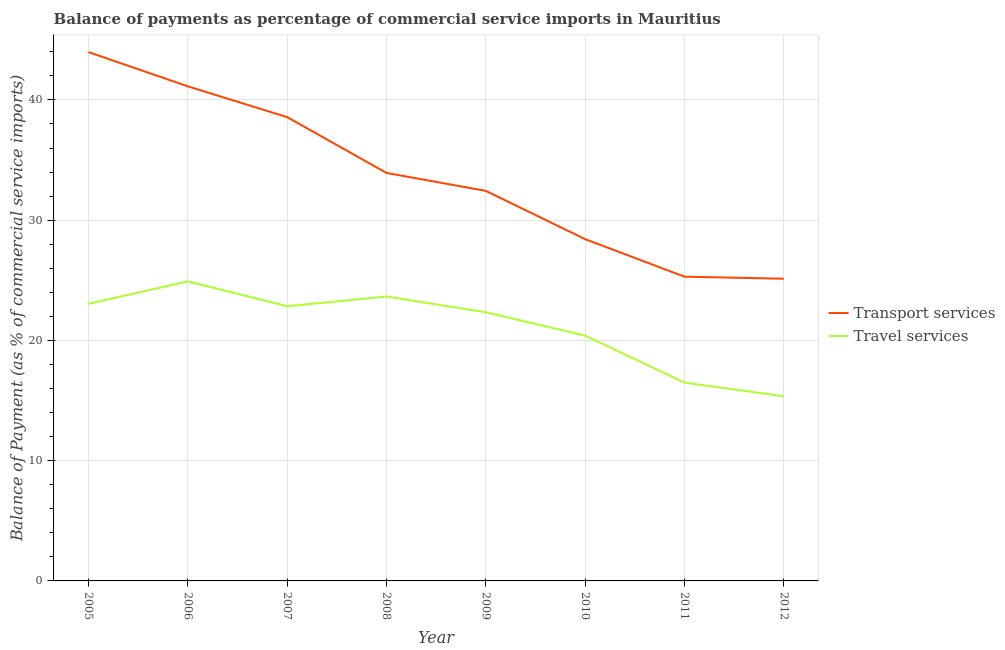Is the number of lines equal to the number of legend labels?
Offer a very short reply. Yes. What is the balance of payments of transport services in 2009?
Keep it short and to the point. 32.44. Across all years, what is the maximum balance of payments of travel services?
Offer a terse response. 24.91. Across all years, what is the minimum balance of payments of travel services?
Provide a succinct answer. 15.35. What is the total balance of payments of travel services in the graph?
Your response must be concise. 169.04. What is the difference between the balance of payments of travel services in 2006 and that in 2010?
Give a very brief answer. 4.51. What is the difference between the balance of payments of travel services in 2005 and the balance of payments of transport services in 2009?
Provide a short and direct response. -9.39. What is the average balance of payments of travel services per year?
Ensure brevity in your answer.  21.13. In the year 2012, what is the difference between the balance of payments of travel services and balance of payments of transport services?
Offer a very short reply. -9.78. In how many years, is the balance of payments of transport services greater than 14 %?
Ensure brevity in your answer.  8. What is the ratio of the balance of payments of travel services in 2008 to that in 2010?
Make the answer very short. 1.16. What is the difference between the highest and the second highest balance of payments of transport services?
Give a very brief answer. 2.85. What is the difference between the highest and the lowest balance of payments of transport services?
Ensure brevity in your answer.  18.85. Does the balance of payments of transport services monotonically increase over the years?
Offer a terse response. No. How many years are there in the graph?
Offer a very short reply. 8. Does the graph contain any zero values?
Provide a short and direct response. No. Does the graph contain grids?
Give a very brief answer. Yes. How many legend labels are there?
Make the answer very short. 2. How are the legend labels stacked?
Keep it short and to the point. Vertical. What is the title of the graph?
Offer a terse response. Balance of payments as percentage of commercial service imports in Mauritius. What is the label or title of the Y-axis?
Keep it short and to the point. Balance of Payment (as % of commercial service imports). What is the Balance of Payment (as % of commercial service imports) in Transport services in 2005?
Give a very brief answer. 43.98. What is the Balance of Payment (as % of commercial service imports) of Travel services in 2005?
Ensure brevity in your answer.  23.05. What is the Balance of Payment (as % of commercial service imports) in Transport services in 2006?
Ensure brevity in your answer.  41.13. What is the Balance of Payment (as % of commercial service imports) in Travel services in 2006?
Your response must be concise. 24.91. What is the Balance of Payment (as % of commercial service imports) in Transport services in 2007?
Your answer should be compact. 38.57. What is the Balance of Payment (as % of commercial service imports) of Travel services in 2007?
Your response must be concise. 22.84. What is the Balance of Payment (as % of commercial service imports) in Transport services in 2008?
Offer a very short reply. 33.93. What is the Balance of Payment (as % of commercial service imports) of Travel services in 2008?
Your answer should be very brief. 23.65. What is the Balance of Payment (as % of commercial service imports) of Transport services in 2009?
Your answer should be compact. 32.44. What is the Balance of Payment (as % of commercial service imports) of Travel services in 2009?
Give a very brief answer. 22.34. What is the Balance of Payment (as % of commercial service imports) in Transport services in 2010?
Keep it short and to the point. 28.42. What is the Balance of Payment (as % of commercial service imports) in Travel services in 2010?
Offer a very short reply. 20.4. What is the Balance of Payment (as % of commercial service imports) of Transport services in 2011?
Provide a short and direct response. 25.3. What is the Balance of Payment (as % of commercial service imports) in Travel services in 2011?
Your answer should be very brief. 16.49. What is the Balance of Payment (as % of commercial service imports) in Transport services in 2012?
Provide a succinct answer. 25.13. What is the Balance of Payment (as % of commercial service imports) of Travel services in 2012?
Your answer should be compact. 15.35. Across all years, what is the maximum Balance of Payment (as % of commercial service imports) in Transport services?
Your answer should be compact. 43.98. Across all years, what is the maximum Balance of Payment (as % of commercial service imports) of Travel services?
Provide a succinct answer. 24.91. Across all years, what is the minimum Balance of Payment (as % of commercial service imports) in Transport services?
Keep it short and to the point. 25.13. Across all years, what is the minimum Balance of Payment (as % of commercial service imports) in Travel services?
Make the answer very short. 15.35. What is the total Balance of Payment (as % of commercial service imports) of Transport services in the graph?
Give a very brief answer. 268.9. What is the total Balance of Payment (as % of commercial service imports) in Travel services in the graph?
Give a very brief answer. 169.04. What is the difference between the Balance of Payment (as % of commercial service imports) of Transport services in 2005 and that in 2006?
Keep it short and to the point. 2.85. What is the difference between the Balance of Payment (as % of commercial service imports) in Travel services in 2005 and that in 2006?
Make the answer very short. -1.86. What is the difference between the Balance of Payment (as % of commercial service imports) of Transport services in 2005 and that in 2007?
Give a very brief answer. 5.41. What is the difference between the Balance of Payment (as % of commercial service imports) in Travel services in 2005 and that in 2007?
Provide a short and direct response. 0.2. What is the difference between the Balance of Payment (as % of commercial service imports) of Transport services in 2005 and that in 2008?
Make the answer very short. 10.05. What is the difference between the Balance of Payment (as % of commercial service imports) in Travel services in 2005 and that in 2008?
Offer a terse response. -0.61. What is the difference between the Balance of Payment (as % of commercial service imports) in Transport services in 2005 and that in 2009?
Ensure brevity in your answer.  11.54. What is the difference between the Balance of Payment (as % of commercial service imports) of Travel services in 2005 and that in 2009?
Keep it short and to the point. 0.7. What is the difference between the Balance of Payment (as % of commercial service imports) in Transport services in 2005 and that in 2010?
Provide a short and direct response. 15.56. What is the difference between the Balance of Payment (as % of commercial service imports) in Travel services in 2005 and that in 2010?
Provide a succinct answer. 2.64. What is the difference between the Balance of Payment (as % of commercial service imports) in Transport services in 2005 and that in 2011?
Ensure brevity in your answer.  18.68. What is the difference between the Balance of Payment (as % of commercial service imports) in Travel services in 2005 and that in 2011?
Ensure brevity in your answer.  6.55. What is the difference between the Balance of Payment (as % of commercial service imports) of Transport services in 2005 and that in 2012?
Keep it short and to the point. 18.85. What is the difference between the Balance of Payment (as % of commercial service imports) of Travel services in 2005 and that in 2012?
Offer a very short reply. 7.69. What is the difference between the Balance of Payment (as % of commercial service imports) of Transport services in 2006 and that in 2007?
Make the answer very short. 2.56. What is the difference between the Balance of Payment (as % of commercial service imports) in Travel services in 2006 and that in 2007?
Offer a terse response. 2.06. What is the difference between the Balance of Payment (as % of commercial service imports) in Transport services in 2006 and that in 2008?
Offer a terse response. 7.2. What is the difference between the Balance of Payment (as % of commercial service imports) in Travel services in 2006 and that in 2008?
Provide a succinct answer. 1.25. What is the difference between the Balance of Payment (as % of commercial service imports) in Transport services in 2006 and that in 2009?
Keep it short and to the point. 8.69. What is the difference between the Balance of Payment (as % of commercial service imports) in Travel services in 2006 and that in 2009?
Your response must be concise. 2.57. What is the difference between the Balance of Payment (as % of commercial service imports) of Transport services in 2006 and that in 2010?
Offer a terse response. 12.71. What is the difference between the Balance of Payment (as % of commercial service imports) of Travel services in 2006 and that in 2010?
Make the answer very short. 4.51. What is the difference between the Balance of Payment (as % of commercial service imports) of Transport services in 2006 and that in 2011?
Offer a terse response. 15.83. What is the difference between the Balance of Payment (as % of commercial service imports) of Travel services in 2006 and that in 2011?
Give a very brief answer. 8.41. What is the difference between the Balance of Payment (as % of commercial service imports) in Transport services in 2006 and that in 2012?
Your answer should be very brief. 16. What is the difference between the Balance of Payment (as % of commercial service imports) of Travel services in 2006 and that in 2012?
Keep it short and to the point. 9.55. What is the difference between the Balance of Payment (as % of commercial service imports) in Transport services in 2007 and that in 2008?
Ensure brevity in your answer.  4.64. What is the difference between the Balance of Payment (as % of commercial service imports) in Travel services in 2007 and that in 2008?
Your answer should be very brief. -0.81. What is the difference between the Balance of Payment (as % of commercial service imports) in Transport services in 2007 and that in 2009?
Provide a succinct answer. 6.14. What is the difference between the Balance of Payment (as % of commercial service imports) of Travel services in 2007 and that in 2009?
Your answer should be compact. 0.5. What is the difference between the Balance of Payment (as % of commercial service imports) of Transport services in 2007 and that in 2010?
Your response must be concise. 10.15. What is the difference between the Balance of Payment (as % of commercial service imports) of Travel services in 2007 and that in 2010?
Your answer should be compact. 2.44. What is the difference between the Balance of Payment (as % of commercial service imports) of Transport services in 2007 and that in 2011?
Your answer should be very brief. 13.27. What is the difference between the Balance of Payment (as % of commercial service imports) of Travel services in 2007 and that in 2011?
Your answer should be compact. 6.35. What is the difference between the Balance of Payment (as % of commercial service imports) in Transport services in 2007 and that in 2012?
Make the answer very short. 13.44. What is the difference between the Balance of Payment (as % of commercial service imports) of Travel services in 2007 and that in 2012?
Offer a very short reply. 7.49. What is the difference between the Balance of Payment (as % of commercial service imports) of Transport services in 2008 and that in 2009?
Offer a very short reply. 1.49. What is the difference between the Balance of Payment (as % of commercial service imports) of Travel services in 2008 and that in 2009?
Give a very brief answer. 1.31. What is the difference between the Balance of Payment (as % of commercial service imports) of Transport services in 2008 and that in 2010?
Offer a very short reply. 5.51. What is the difference between the Balance of Payment (as % of commercial service imports) of Travel services in 2008 and that in 2010?
Your response must be concise. 3.25. What is the difference between the Balance of Payment (as % of commercial service imports) in Transport services in 2008 and that in 2011?
Provide a short and direct response. 8.63. What is the difference between the Balance of Payment (as % of commercial service imports) in Travel services in 2008 and that in 2011?
Provide a succinct answer. 7.16. What is the difference between the Balance of Payment (as % of commercial service imports) of Transport services in 2008 and that in 2012?
Your answer should be compact. 8.8. What is the difference between the Balance of Payment (as % of commercial service imports) of Travel services in 2008 and that in 2012?
Make the answer very short. 8.3. What is the difference between the Balance of Payment (as % of commercial service imports) in Transport services in 2009 and that in 2010?
Provide a succinct answer. 4.01. What is the difference between the Balance of Payment (as % of commercial service imports) in Travel services in 2009 and that in 2010?
Provide a short and direct response. 1.94. What is the difference between the Balance of Payment (as % of commercial service imports) of Transport services in 2009 and that in 2011?
Provide a short and direct response. 7.14. What is the difference between the Balance of Payment (as % of commercial service imports) in Travel services in 2009 and that in 2011?
Your answer should be compact. 5.85. What is the difference between the Balance of Payment (as % of commercial service imports) in Transport services in 2009 and that in 2012?
Keep it short and to the point. 7.3. What is the difference between the Balance of Payment (as % of commercial service imports) in Travel services in 2009 and that in 2012?
Offer a terse response. 6.99. What is the difference between the Balance of Payment (as % of commercial service imports) of Transport services in 2010 and that in 2011?
Give a very brief answer. 3.12. What is the difference between the Balance of Payment (as % of commercial service imports) of Travel services in 2010 and that in 2011?
Make the answer very short. 3.91. What is the difference between the Balance of Payment (as % of commercial service imports) of Transport services in 2010 and that in 2012?
Give a very brief answer. 3.29. What is the difference between the Balance of Payment (as % of commercial service imports) in Travel services in 2010 and that in 2012?
Your response must be concise. 5.05. What is the difference between the Balance of Payment (as % of commercial service imports) in Transport services in 2011 and that in 2012?
Keep it short and to the point. 0.17. What is the difference between the Balance of Payment (as % of commercial service imports) in Travel services in 2011 and that in 2012?
Provide a short and direct response. 1.14. What is the difference between the Balance of Payment (as % of commercial service imports) in Transport services in 2005 and the Balance of Payment (as % of commercial service imports) in Travel services in 2006?
Provide a succinct answer. 19.07. What is the difference between the Balance of Payment (as % of commercial service imports) of Transport services in 2005 and the Balance of Payment (as % of commercial service imports) of Travel services in 2007?
Make the answer very short. 21.14. What is the difference between the Balance of Payment (as % of commercial service imports) of Transport services in 2005 and the Balance of Payment (as % of commercial service imports) of Travel services in 2008?
Provide a short and direct response. 20.33. What is the difference between the Balance of Payment (as % of commercial service imports) in Transport services in 2005 and the Balance of Payment (as % of commercial service imports) in Travel services in 2009?
Provide a succinct answer. 21.64. What is the difference between the Balance of Payment (as % of commercial service imports) of Transport services in 2005 and the Balance of Payment (as % of commercial service imports) of Travel services in 2010?
Ensure brevity in your answer.  23.58. What is the difference between the Balance of Payment (as % of commercial service imports) in Transport services in 2005 and the Balance of Payment (as % of commercial service imports) in Travel services in 2011?
Provide a succinct answer. 27.48. What is the difference between the Balance of Payment (as % of commercial service imports) of Transport services in 2005 and the Balance of Payment (as % of commercial service imports) of Travel services in 2012?
Make the answer very short. 28.62. What is the difference between the Balance of Payment (as % of commercial service imports) of Transport services in 2006 and the Balance of Payment (as % of commercial service imports) of Travel services in 2007?
Provide a succinct answer. 18.29. What is the difference between the Balance of Payment (as % of commercial service imports) of Transport services in 2006 and the Balance of Payment (as % of commercial service imports) of Travel services in 2008?
Provide a short and direct response. 17.48. What is the difference between the Balance of Payment (as % of commercial service imports) in Transport services in 2006 and the Balance of Payment (as % of commercial service imports) in Travel services in 2009?
Keep it short and to the point. 18.79. What is the difference between the Balance of Payment (as % of commercial service imports) in Transport services in 2006 and the Balance of Payment (as % of commercial service imports) in Travel services in 2010?
Provide a succinct answer. 20.73. What is the difference between the Balance of Payment (as % of commercial service imports) of Transport services in 2006 and the Balance of Payment (as % of commercial service imports) of Travel services in 2011?
Your answer should be compact. 24.64. What is the difference between the Balance of Payment (as % of commercial service imports) of Transport services in 2006 and the Balance of Payment (as % of commercial service imports) of Travel services in 2012?
Keep it short and to the point. 25.78. What is the difference between the Balance of Payment (as % of commercial service imports) of Transport services in 2007 and the Balance of Payment (as % of commercial service imports) of Travel services in 2008?
Provide a succinct answer. 14.92. What is the difference between the Balance of Payment (as % of commercial service imports) in Transport services in 2007 and the Balance of Payment (as % of commercial service imports) in Travel services in 2009?
Provide a short and direct response. 16.23. What is the difference between the Balance of Payment (as % of commercial service imports) in Transport services in 2007 and the Balance of Payment (as % of commercial service imports) in Travel services in 2010?
Your answer should be very brief. 18.17. What is the difference between the Balance of Payment (as % of commercial service imports) of Transport services in 2007 and the Balance of Payment (as % of commercial service imports) of Travel services in 2011?
Provide a short and direct response. 22.08. What is the difference between the Balance of Payment (as % of commercial service imports) of Transport services in 2007 and the Balance of Payment (as % of commercial service imports) of Travel services in 2012?
Offer a very short reply. 23.22. What is the difference between the Balance of Payment (as % of commercial service imports) in Transport services in 2008 and the Balance of Payment (as % of commercial service imports) in Travel services in 2009?
Make the answer very short. 11.59. What is the difference between the Balance of Payment (as % of commercial service imports) of Transport services in 2008 and the Balance of Payment (as % of commercial service imports) of Travel services in 2010?
Provide a short and direct response. 13.53. What is the difference between the Balance of Payment (as % of commercial service imports) in Transport services in 2008 and the Balance of Payment (as % of commercial service imports) in Travel services in 2011?
Provide a succinct answer. 17.43. What is the difference between the Balance of Payment (as % of commercial service imports) of Transport services in 2008 and the Balance of Payment (as % of commercial service imports) of Travel services in 2012?
Provide a succinct answer. 18.57. What is the difference between the Balance of Payment (as % of commercial service imports) of Transport services in 2009 and the Balance of Payment (as % of commercial service imports) of Travel services in 2010?
Provide a succinct answer. 12.04. What is the difference between the Balance of Payment (as % of commercial service imports) of Transport services in 2009 and the Balance of Payment (as % of commercial service imports) of Travel services in 2011?
Provide a short and direct response. 15.94. What is the difference between the Balance of Payment (as % of commercial service imports) in Transport services in 2009 and the Balance of Payment (as % of commercial service imports) in Travel services in 2012?
Ensure brevity in your answer.  17.08. What is the difference between the Balance of Payment (as % of commercial service imports) in Transport services in 2010 and the Balance of Payment (as % of commercial service imports) in Travel services in 2011?
Provide a short and direct response. 11.93. What is the difference between the Balance of Payment (as % of commercial service imports) of Transport services in 2010 and the Balance of Payment (as % of commercial service imports) of Travel services in 2012?
Offer a terse response. 13.07. What is the difference between the Balance of Payment (as % of commercial service imports) in Transport services in 2011 and the Balance of Payment (as % of commercial service imports) in Travel services in 2012?
Ensure brevity in your answer.  9.95. What is the average Balance of Payment (as % of commercial service imports) of Transport services per year?
Keep it short and to the point. 33.61. What is the average Balance of Payment (as % of commercial service imports) of Travel services per year?
Offer a terse response. 21.13. In the year 2005, what is the difference between the Balance of Payment (as % of commercial service imports) of Transport services and Balance of Payment (as % of commercial service imports) of Travel services?
Provide a succinct answer. 20.93. In the year 2006, what is the difference between the Balance of Payment (as % of commercial service imports) in Transport services and Balance of Payment (as % of commercial service imports) in Travel services?
Provide a short and direct response. 16.22. In the year 2007, what is the difference between the Balance of Payment (as % of commercial service imports) in Transport services and Balance of Payment (as % of commercial service imports) in Travel services?
Offer a very short reply. 15.73. In the year 2008, what is the difference between the Balance of Payment (as % of commercial service imports) in Transport services and Balance of Payment (as % of commercial service imports) in Travel services?
Make the answer very short. 10.28. In the year 2009, what is the difference between the Balance of Payment (as % of commercial service imports) in Transport services and Balance of Payment (as % of commercial service imports) in Travel services?
Keep it short and to the point. 10.09. In the year 2010, what is the difference between the Balance of Payment (as % of commercial service imports) of Transport services and Balance of Payment (as % of commercial service imports) of Travel services?
Give a very brief answer. 8.02. In the year 2011, what is the difference between the Balance of Payment (as % of commercial service imports) in Transport services and Balance of Payment (as % of commercial service imports) in Travel services?
Offer a very short reply. 8.81. In the year 2012, what is the difference between the Balance of Payment (as % of commercial service imports) in Transport services and Balance of Payment (as % of commercial service imports) in Travel services?
Ensure brevity in your answer.  9.78. What is the ratio of the Balance of Payment (as % of commercial service imports) in Transport services in 2005 to that in 2006?
Your answer should be compact. 1.07. What is the ratio of the Balance of Payment (as % of commercial service imports) of Travel services in 2005 to that in 2006?
Your answer should be very brief. 0.93. What is the ratio of the Balance of Payment (as % of commercial service imports) in Transport services in 2005 to that in 2007?
Your response must be concise. 1.14. What is the ratio of the Balance of Payment (as % of commercial service imports) in Travel services in 2005 to that in 2007?
Provide a succinct answer. 1.01. What is the ratio of the Balance of Payment (as % of commercial service imports) of Transport services in 2005 to that in 2008?
Your answer should be compact. 1.3. What is the ratio of the Balance of Payment (as % of commercial service imports) in Travel services in 2005 to that in 2008?
Ensure brevity in your answer.  0.97. What is the ratio of the Balance of Payment (as % of commercial service imports) in Transport services in 2005 to that in 2009?
Offer a terse response. 1.36. What is the ratio of the Balance of Payment (as % of commercial service imports) of Travel services in 2005 to that in 2009?
Make the answer very short. 1.03. What is the ratio of the Balance of Payment (as % of commercial service imports) in Transport services in 2005 to that in 2010?
Offer a very short reply. 1.55. What is the ratio of the Balance of Payment (as % of commercial service imports) in Travel services in 2005 to that in 2010?
Give a very brief answer. 1.13. What is the ratio of the Balance of Payment (as % of commercial service imports) of Transport services in 2005 to that in 2011?
Your answer should be very brief. 1.74. What is the ratio of the Balance of Payment (as % of commercial service imports) of Travel services in 2005 to that in 2011?
Provide a short and direct response. 1.4. What is the ratio of the Balance of Payment (as % of commercial service imports) of Transport services in 2005 to that in 2012?
Offer a terse response. 1.75. What is the ratio of the Balance of Payment (as % of commercial service imports) in Travel services in 2005 to that in 2012?
Offer a very short reply. 1.5. What is the ratio of the Balance of Payment (as % of commercial service imports) in Transport services in 2006 to that in 2007?
Provide a short and direct response. 1.07. What is the ratio of the Balance of Payment (as % of commercial service imports) in Travel services in 2006 to that in 2007?
Your answer should be very brief. 1.09. What is the ratio of the Balance of Payment (as % of commercial service imports) in Transport services in 2006 to that in 2008?
Provide a succinct answer. 1.21. What is the ratio of the Balance of Payment (as % of commercial service imports) of Travel services in 2006 to that in 2008?
Give a very brief answer. 1.05. What is the ratio of the Balance of Payment (as % of commercial service imports) of Transport services in 2006 to that in 2009?
Keep it short and to the point. 1.27. What is the ratio of the Balance of Payment (as % of commercial service imports) of Travel services in 2006 to that in 2009?
Provide a short and direct response. 1.11. What is the ratio of the Balance of Payment (as % of commercial service imports) of Transport services in 2006 to that in 2010?
Ensure brevity in your answer.  1.45. What is the ratio of the Balance of Payment (as % of commercial service imports) of Travel services in 2006 to that in 2010?
Your answer should be very brief. 1.22. What is the ratio of the Balance of Payment (as % of commercial service imports) of Transport services in 2006 to that in 2011?
Provide a succinct answer. 1.63. What is the ratio of the Balance of Payment (as % of commercial service imports) in Travel services in 2006 to that in 2011?
Provide a succinct answer. 1.51. What is the ratio of the Balance of Payment (as % of commercial service imports) in Transport services in 2006 to that in 2012?
Make the answer very short. 1.64. What is the ratio of the Balance of Payment (as % of commercial service imports) in Travel services in 2006 to that in 2012?
Your answer should be compact. 1.62. What is the ratio of the Balance of Payment (as % of commercial service imports) in Transport services in 2007 to that in 2008?
Your response must be concise. 1.14. What is the ratio of the Balance of Payment (as % of commercial service imports) of Travel services in 2007 to that in 2008?
Ensure brevity in your answer.  0.97. What is the ratio of the Balance of Payment (as % of commercial service imports) in Transport services in 2007 to that in 2009?
Your answer should be compact. 1.19. What is the ratio of the Balance of Payment (as % of commercial service imports) of Travel services in 2007 to that in 2009?
Your response must be concise. 1.02. What is the ratio of the Balance of Payment (as % of commercial service imports) in Transport services in 2007 to that in 2010?
Give a very brief answer. 1.36. What is the ratio of the Balance of Payment (as % of commercial service imports) in Travel services in 2007 to that in 2010?
Keep it short and to the point. 1.12. What is the ratio of the Balance of Payment (as % of commercial service imports) of Transport services in 2007 to that in 2011?
Provide a short and direct response. 1.52. What is the ratio of the Balance of Payment (as % of commercial service imports) in Travel services in 2007 to that in 2011?
Make the answer very short. 1.38. What is the ratio of the Balance of Payment (as % of commercial service imports) of Transport services in 2007 to that in 2012?
Your answer should be compact. 1.53. What is the ratio of the Balance of Payment (as % of commercial service imports) in Travel services in 2007 to that in 2012?
Offer a terse response. 1.49. What is the ratio of the Balance of Payment (as % of commercial service imports) in Transport services in 2008 to that in 2009?
Provide a short and direct response. 1.05. What is the ratio of the Balance of Payment (as % of commercial service imports) in Travel services in 2008 to that in 2009?
Provide a succinct answer. 1.06. What is the ratio of the Balance of Payment (as % of commercial service imports) of Transport services in 2008 to that in 2010?
Ensure brevity in your answer.  1.19. What is the ratio of the Balance of Payment (as % of commercial service imports) in Travel services in 2008 to that in 2010?
Give a very brief answer. 1.16. What is the ratio of the Balance of Payment (as % of commercial service imports) in Transport services in 2008 to that in 2011?
Offer a terse response. 1.34. What is the ratio of the Balance of Payment (as % of commercial service imports) of Travel services in 2008 to that in 2011?
Offer a terse response. 1.43. What is the ratio of the Balance of Payment (as % of commercial service imports) in Transport services in 2008 to that in 2012?
Offer a very short reply. 1.35. What is the ratio of the Balance of Payment (as % of commercial service imports) of Travel services in 2008 to that in 2012?
Your answer should be very brief. 1.54. What is the ratio of the Balance of Payment (as % of commercial service imports) of Transport services in 2009 to that in 2010?
Your response must be concise. 1.14. What is the ratio of the Balance of Payment (as % of commercial service imports) of Travel services in 2009 to that in 2010?
Keep it short and to the point. 1.1. What is the ratio of the Balance of Payment (as % of commercial service imports) in Transport services in 2009 to that in 2011?
Provide a succinct answer. 1.28. What is the ratio of the Balance of Payment (as % of commercial service imports) of Travel services in 2009 to that in 2011?
Offer a terse response. 1.35. What is the ratio of the Balance of Payment (as % of commercial service imports) of Transport services in 2009 to that in 2012?
Give a very brief answer. 1.29. What is the ratio of the Balance of Payment (as % of commercial service imports) in Travel services in 2009 to that in 2012?
Ensure brevity in your answer.  1.46. What is the ratio of the Balance of Payment (as % of commercial service imports) of Transport services in 2010 to that in 2011?
Provide a succinct answer. 1.12. What is the ratio of the Balance of Payment (as % of commercial service imports) in Travel services in 2010 to that in 2011?
Your answer should be compact. 1.24. What is the ratio of the Balance of Payment (as % of commercial service imports) in Transport services in 2010 to that in 2012?
Provide a succinct answer. 1.13. What is the ratio of the Balance of Payment (as % of commercial service imports) of Travel services in 2010 to that in 2012?
Your answer should be compact. 1.33. What is the ratio of the Balance of Payment (as % of commercial service imports) in Travel services in 2011 to that in 2012?
Give a very brief answer. 1.07. What is the difference between the highest and the second highest Balance of Payment (as % of commercial service imports) in Transport services?
Offer a terse response. 2.85. What is the difference between the highest and the second highest Balance of Payment (as % of commercial service imports) of Travel services?
Your answer should be compact. 1.25. What is the difference between the highest and the lowest Balance of Payment (as % of commercial service imports) in Transport services?
Make the answer very short. 18.85. What is the difference between the highest and the lowest Balance of Payment (as % of commercial service imports) of Travel services?
Provide a short and direct response. 9.55. 